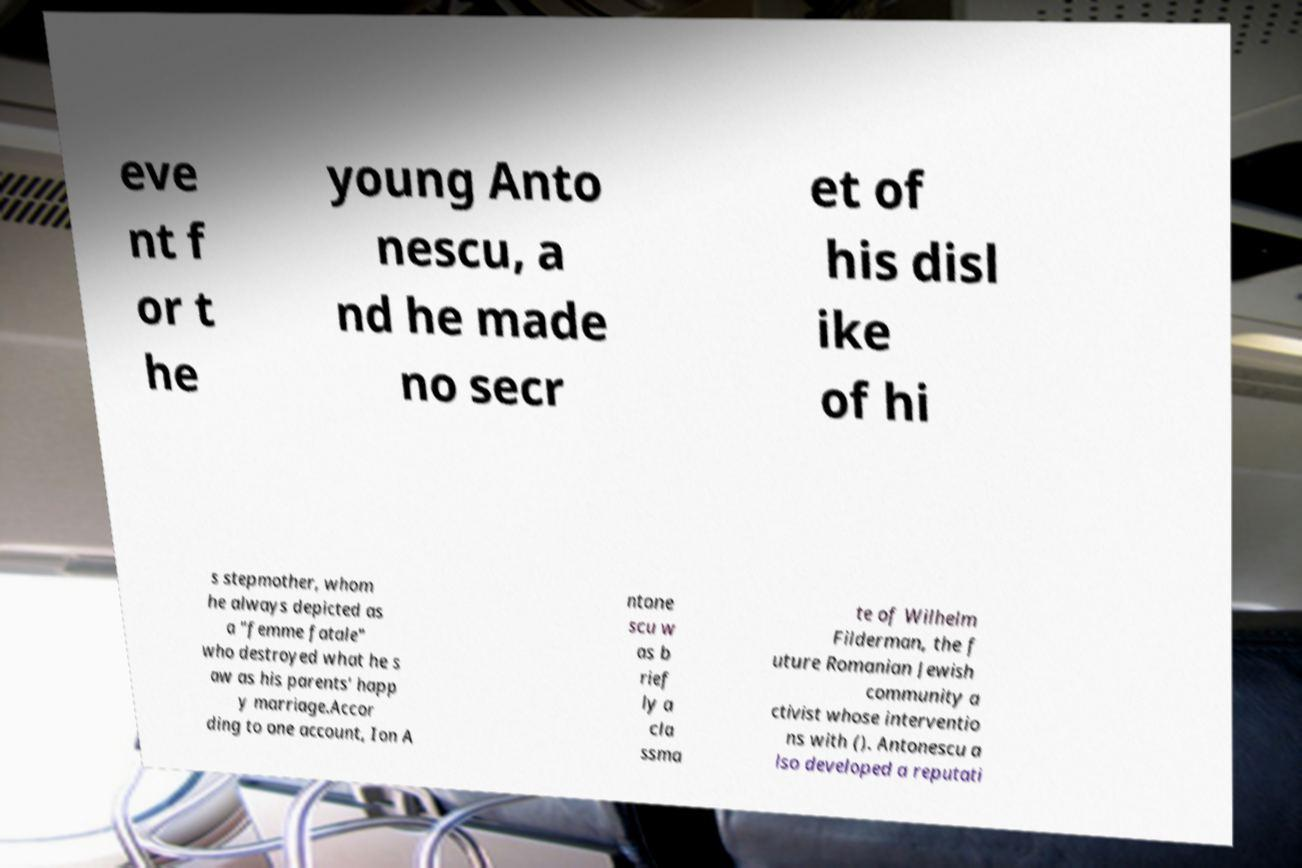Can you read and provide the text displayed in the image?This photo seems to have some interesting text. Can you extract and type it out for me? eve nt f or t he young Anto nescu, a nd he made no secr et of his disl ike of hi s stepmother, whom he always depicted as a "femme fatale" who destroyed what he s aw as his parents' happ y marriage.Accor ding to one account, Ion A ntone scu w as b rief ly a cla ssma te of Wilhelm Filderman, the f uture Romanian Jewish community a ctivist whose interventio ns with (). Antonescu a lso developed a reputati 